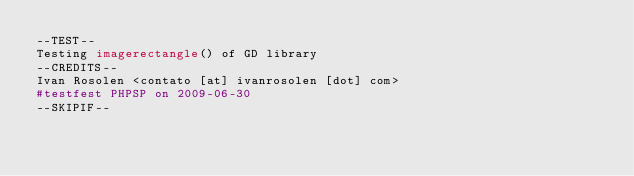<code> <loc_0><loc_0><loc_500><loc_500><_PHP_>--TEST-- 
Testing imagerectangle() of GD library 
--CREDITS-- 
Ivan Rosolen <contato [at] ivanrosolen [dot] com> 
#testfest PHPSP on 2009-06-30
--SKIPIF-- </code> 